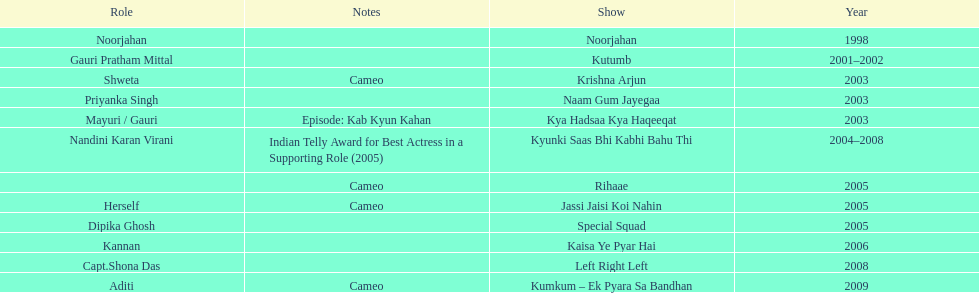How many shows were there in 2005? 3. 